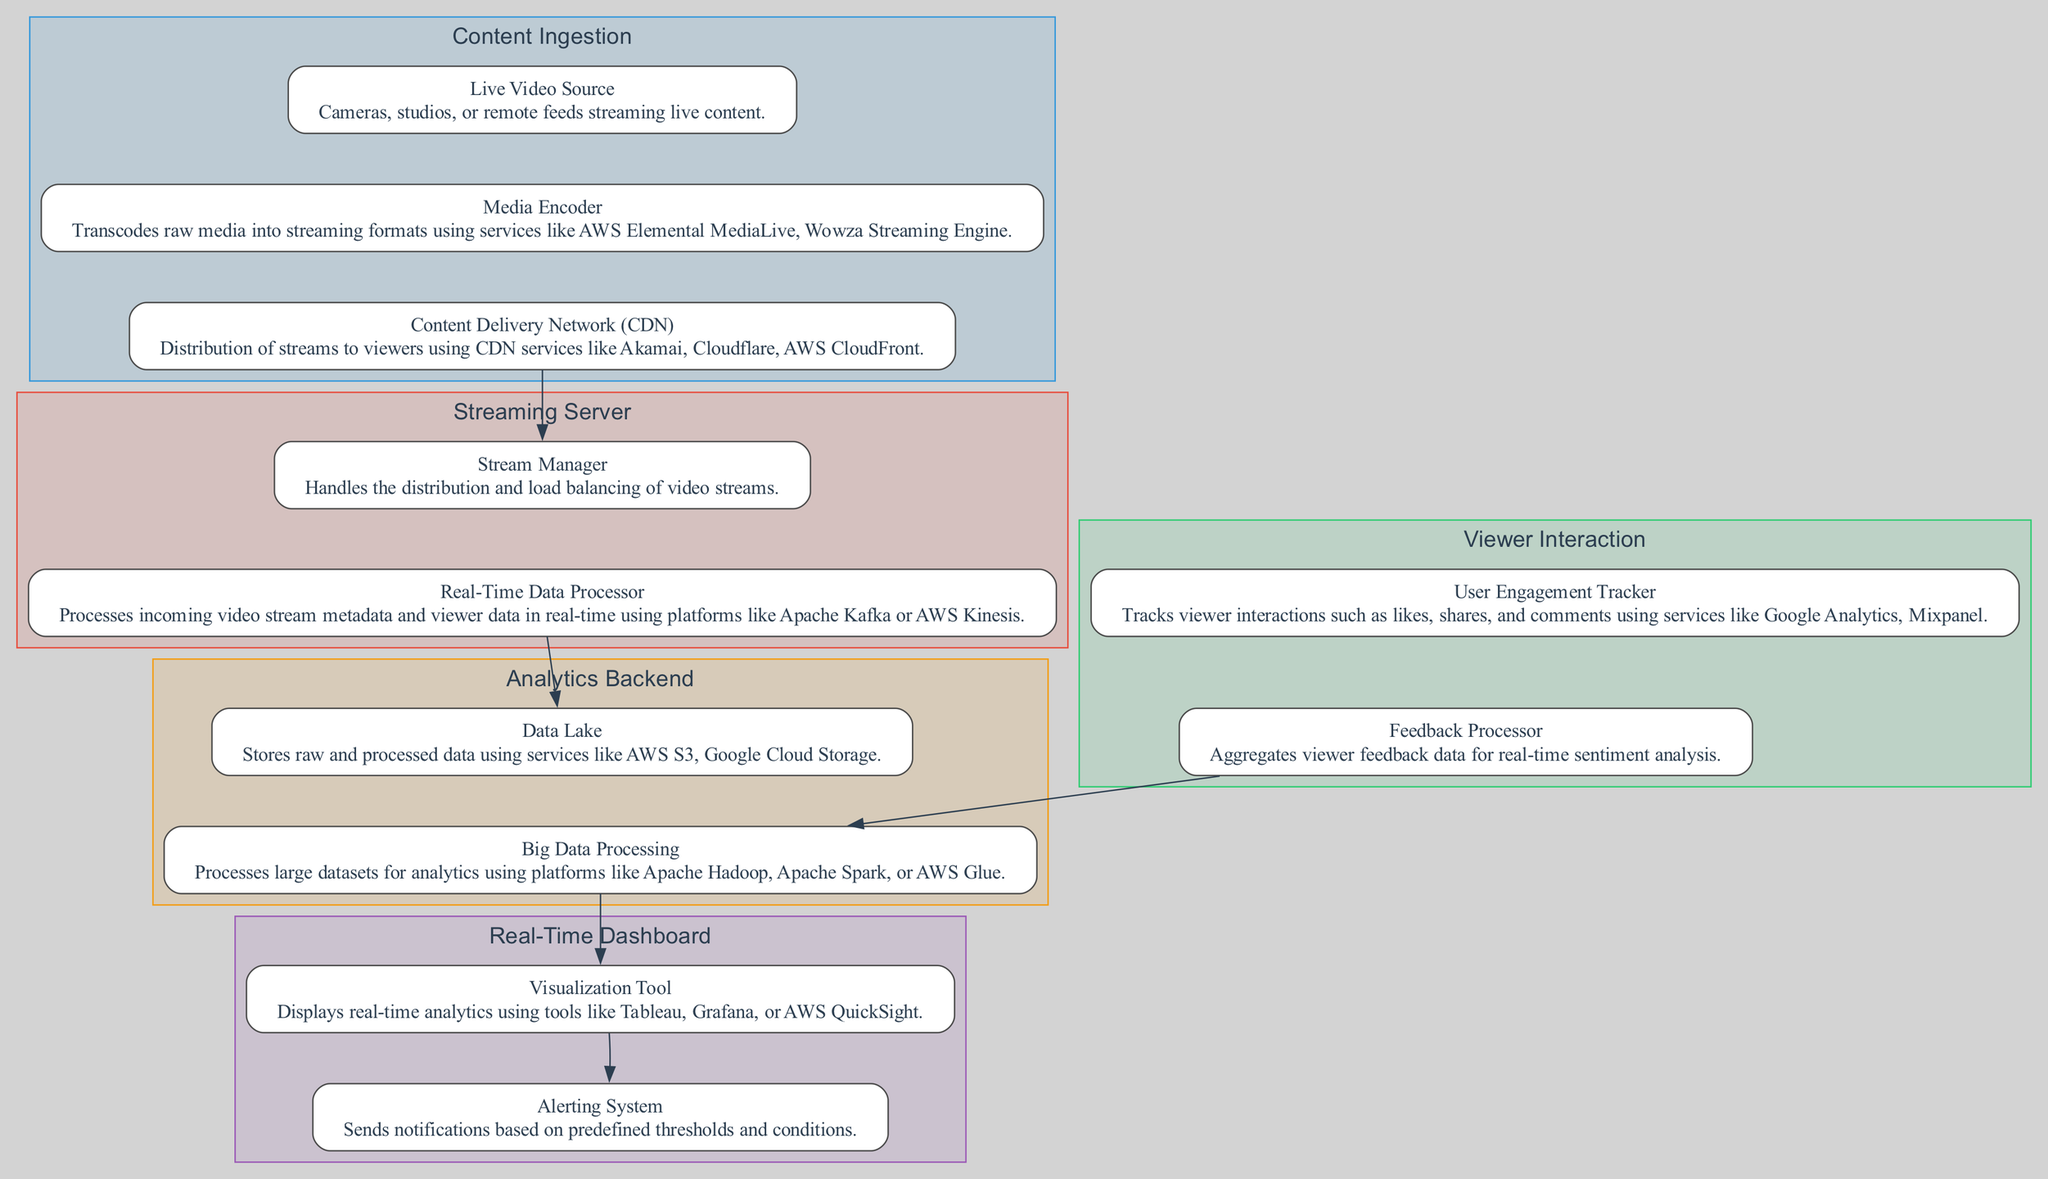What is the first component in the Content Ingestion section? The first component listed under the Content Ingestion section is the Live Video Source, which describes the sources of live video such as cameras and studios.
Answer: Live Video Source How many components are in the Streaming Server section? The Streaming Server section contains two components: Stream Manager and Real-Time Data Processor. Each of these components is necessary for managing the distribution of live streams.
Answer: 2 Which component processes viewer data in real-time? The component that processes viewer data in real-time is the Real-Time Data Processor. It utilizes platforms like Apache Kafka or AWS Kinesis for this purpose.
Answer: Real-Time Data Processor What links the Viewer Interaction and Analytics Backend sections? The Feedback Processor links the Viewer Interaction and Analytics Backend sections, as it sends aggregated viewer feedback data to the Big Data Processing component for further analysis.
Answer: Feedback Processor What is the primary role of the Real-Time Dashboard? The primary role of the Real-Time Dashboard is to provide insights and reports on viewership and engagement, displaying relevant analytics in real-time.
Answer: Provide insights and reports Which component is responsible for storing raw and processed data? The Data Lake is responsible for storing both raw and processed data within the Analytics Backend section, utilizing cloud storage solutions.
Answer: Data Lake What is the relationship between Big Data Processing and Visualization Tool? The Big Data Processing component sends processed data to the Visualization Tool, which displays the analytics for real-time viewership metrics to users.
Answer: Sends processed data How many sections are there in the block diagram? The block diagram consists of five sections: Content Ingestion, Streaming Server, Viewer Interaction, Analytics Backend, and Real-Time Dashboard, each serving different purposes in the broadcasting pipeline.
Answer: 5 What component alerts users based on predefined thresholds? The component responsible for alerting users based on predefined thresholds is the Alerting System, which is part of the Real-Time Dashboard.
Answer: Alerting System 